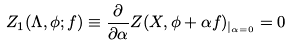Convert formula to latex. <formula><loc_0><loc_0><loc_500><loc_500>Z _ { 1 } ( \Lambda , \phi ; f ) \equiv \frac { \partial } { \partial \alpha } Z ( X , \phi + \alpha f ) _ { | _ { \alpha = 0 } } = 0</formula> 